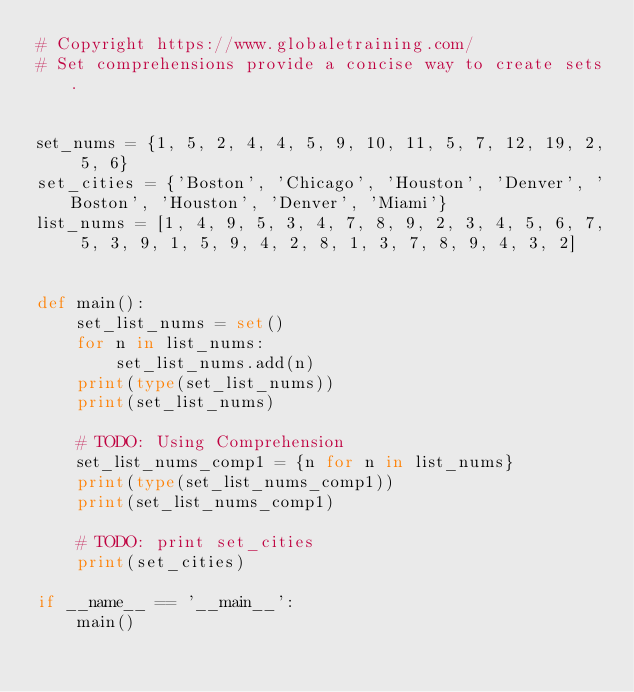<code> <loc_0><loc_0><loc_500><loc_500><_Python_># Copyright https://www.globaletraining.com/
# Set comprehensions provide a concise way to create sets.


set_nums = {1, 5, 2, 4, 4, 5, 9, 10, 11, 5, 7, 12, 19, 2, 5, 6}
set_cities = {'Boston', 'Chicago', 'Houston', 'Denver', 'Boston', 'Houston', 'Denver', 'Miami'}
list_nums = [1, 4, 9, 5, 3, 4, 7, 8, 9, 2, 3, 4, 5, 6, 7, 5, 3, 9, 1, 5, 9, 4, 2, 8, 1, 3, 7, 8, 9, 4, 3, 2]


def main():
    set_list_nums = set()
    for n in list_nums:
        set_list_nums.add(n)
    print(type(set_list_nums))
    print(set_list_nums)

    # TODO: Using Comprehension
    set_list_nums_comp1 = {n for n in list_nums}
    print(type(set_list_nums_comp1))
    print(set_list_nums_comp1)

    # TODO: print set_cities
    print(set_cities)

if __name__ == '__main__':
    main()</code> 